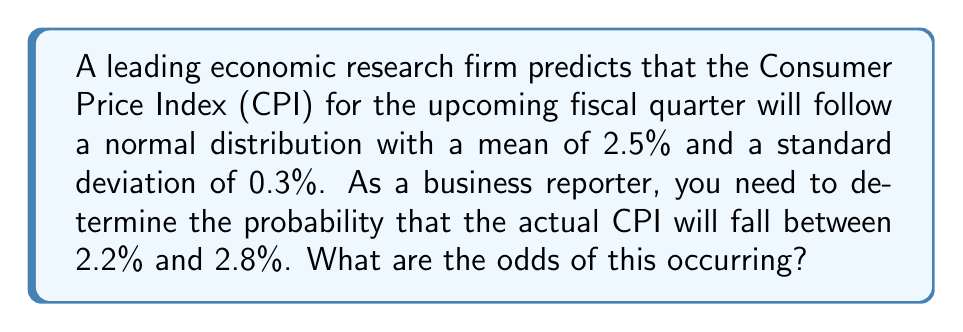Help me with this question. To solve this problem, we'll follow these steps:

1) First, we need to standardize the given range using the z-score formula:

   $z = \frac{x - \mu}{\sigma}$

   Where $x$ is the value, $\mu$ is the mean, and $\sigma$ is the standard deviation.

2) For the lower bound (2.2%):
   $z_1 = \frac{2.2 - 2.5}{0.3} = -1$

3) For the upper bound (2.8%):
   $z_2 = \frac{2.8 - 2.5}{0.3} = 1$

4) Now, we need to find the area under the standard normal curve between $z_1$ and $z_2$.

5) Using a standard normal distribution table or calculator:
   $P(-1 \leq Z \leq 1) = P(Z \leq 1) - P(Z \leq -1)$
                        $= 0.8413 - 0.1587$
                        $= 0.6826$

6) To convert this probability to odds, we use the formula:
   $\text{Odds} = \frac{p}{1-p}$

   Where $p$ is the probability.

7) Substituting our probability:
   $\text{Odds} = \frac{0.6826}{1-0.6826} = \frac{0.6826}{0.3174} \approx 2.15$

Therefore, the odds are approximately 2.15 to 1 in favor of the CPI falling between 2.2% and 2.8%.
Answer: 2.15 to 1 